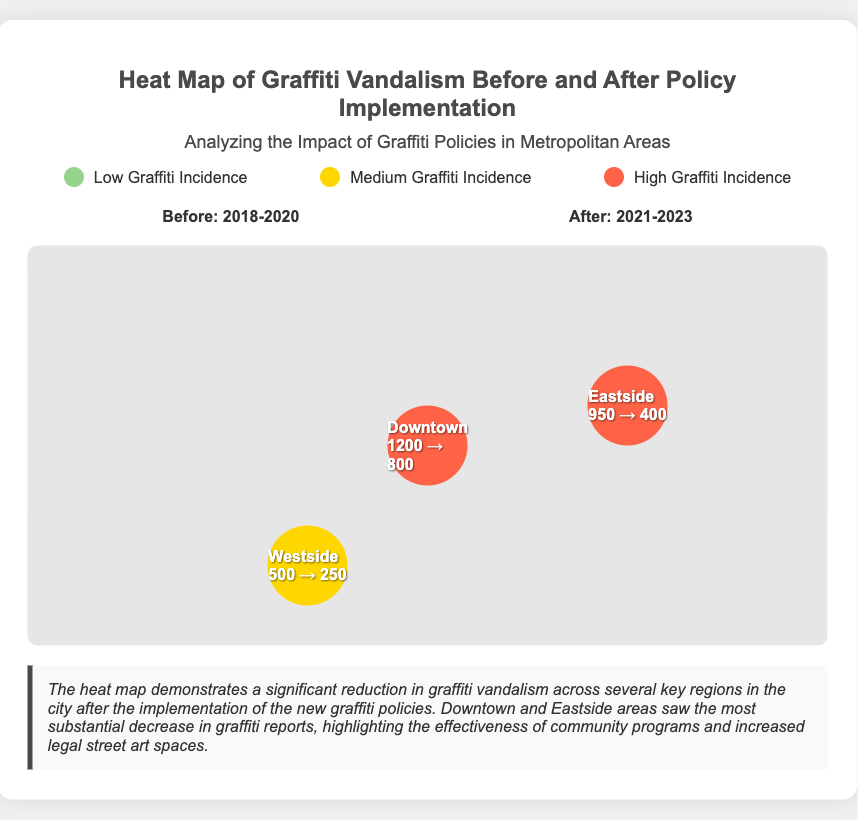What is the title of the heat map? The title of the heat map is indicated at the top of the document.
Answer: Heat Map of Graffiti Vandalism Before and After Policy Implementation What are the years before policy implementation? The years before the policy implementation are specified in the timeframe section.
Answer: 2018-2020 What color represents high graffiti incidence? The colors that represent different levels of graffiti incidence are described in the legend.
Answer: Red Which area experienced a reduction from 950 to 400 incidents? The specific areas with graffiti statistics are mentioned in the map container.
Answer: Eastside What was the graffiti incident count in Downtown after the policy? The incident counts for each area before and after policy implementation are listed in the regions.
Answer: 800 Which area had a medium level of graffiti incidence before the policy implementation? The legend provides information on incidence levels, and the areas are detailed on the map.
Answer: Westside What does the summary comment on graffiti vandalism trends? The summary reflects on the effectiveness of the policies and changes in graffiti reports.
Answer: Significant reduction What timeframe follows the policy implementation? The timeframe following the policy implementation is stated explicitly in the timeframe section.
Answer: 2021-2023 